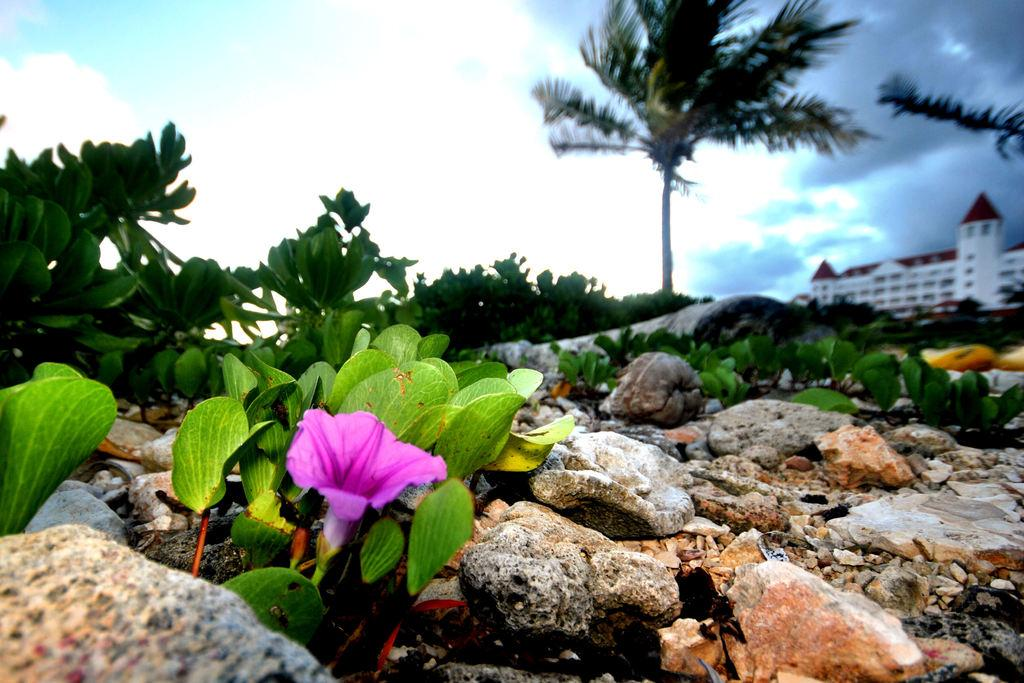What type of plant can be seen in the image? There is a flower in the image. What other objects are present in the image? There are stones and plants visible in the image. What can be seen in the background of the image? There is a building, trees, and the sky visible in the background of the image. What is the condition of the sky in the image? Clouds are present in the sky in the image. What type of ink is used to write the caption on the image? There is no caption present in the image, so it is not possible to determine the type of ink used. 